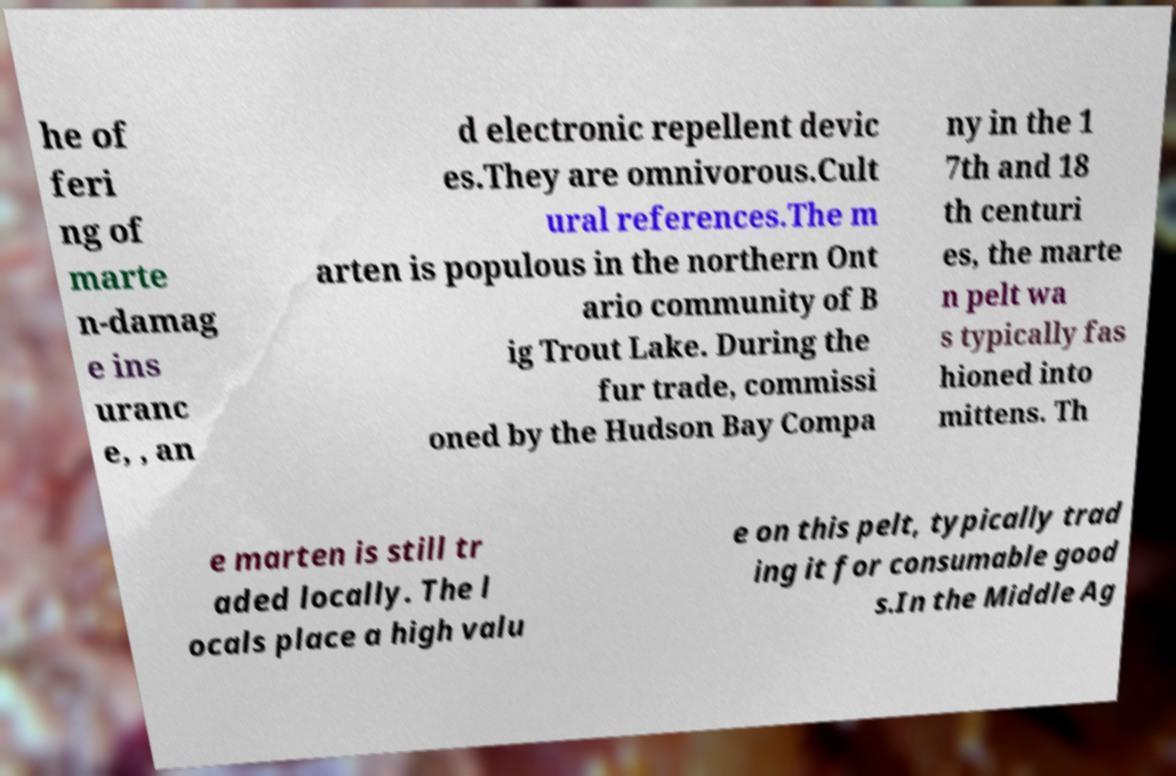For documentation purposes, I need the text within this image transcribed. Could you provide that? he of feri ng of marte n-damag e ins uranc e, , an d electronic repellent devic es.They are omnivorous.Cult ural references.The m arten is populous in the northern Ont ario community of B ig Trout Lake. During the fur trade, commissi oned by the Hudson Bay Compa ny in the 1 7th and 18 th centuri es, the marte n pelt wa s typically fas hioned into mittens. Th e marten is still tr aded locally. The l ocals place a high valu e on this pelt, typically trad ing it for consumable good s.In the Middle Ag 